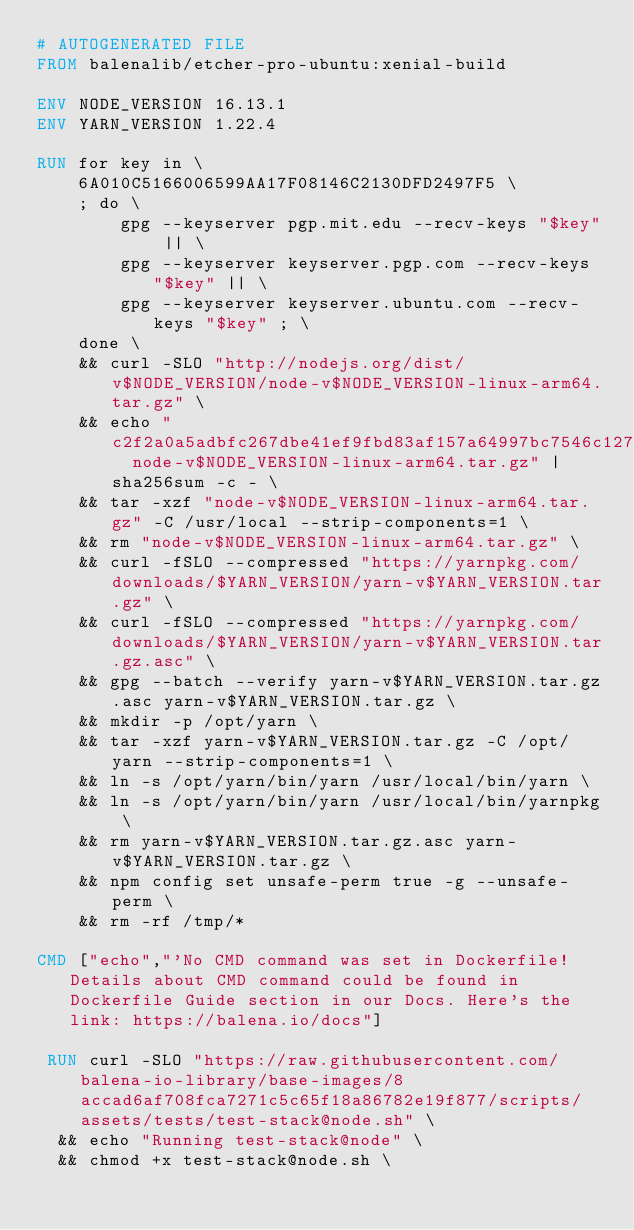Convert code to text. <code><loc_0><loc_0><loc_500><loc_500><_Dockerfile_># AUTOGENERATED FILE
FROM balenalib/etcher-pro-ubuntu:xenial-build

ENV NODE_VERSION 16.13.1
ENV YARN_VERSION 1.22.4

RUN for key in \
	6A010C5166006599AA17F08146C2130DFD2497F5 \
	; do \
		gpg --keyserver pgp.mit.edu --recv-keys "$key" || \
		gpg --keyserver keyserver.pgp.com --recv-keys "$key" || \
		gpg --keyserver keyserver.ubuntu.com --recv-keys "$key" ; \
	done \
	&& curl -SLO "http://nodejs.org/dist/v$NODE_VERSION/node-v$NODE_VERSION-linux-arm64.tar.gz" \
	&& echo "c2f2a0a5adbfc267dbe41ef9fbd83af157a64997bc7546c12717ff55ea6b57d8  node-v$NODE_VERSION-linux-arm64.tar.gz" | sha256sum -c - \
	&& tar -xzf "node-v$NODE_VERSION-linux-arm64.tar.gz" -C /usr/local --strip-components=1 \
	&& rm "node-v$NODE_VERSION-linux-arm64.tar.gz" \
	&& curl -fSLO --compressed "https://yarnpkg.com/downloads/$YARN_VERSION/yarn-v$YARN_VERSION.tar.gz" \
	&& curl -fSLO --compressed "https://yarnpkg.com/downloads/$YARN_VERSION/yarn-v$YARN_VERSION.tar.gz.asc" \
	&& gpg --batch --verify yarn-v$YARN_VERSION.tar.gz.asc yarn-v$YARN_VERSION.tar.gz \
	&& mkdir -p /opt/yarn \
	&& tar -xzf yarn-v$YARN_VERSION.tar.gz -C /opt/yarn --strip-components=1 \
	&& ln -s /opt/yarn/bin/yarn /usr/local/bin/yarn \
	&& ln -s /opt/yarn/bin/yarn /usr/local/bin/yarnpkg \
	&& rm yarn-v$YARN_VERSION.tar.gz.asc yarn-v$YARN_VERSION.tar.gz \
	&& npm config set unsafe-perm true -g --unsafe-perm \
	&& rm -rf /tmp/*

CMD ["echo","'No CMD command was set in Dockerfile! Details about CMD command could be found in Dockerfile Guide section in our Docs. Here's the link: https://balena.io/docs"]

 RUN curl -SLO "https://raw.githubusercontent.com/balena-io-library/base-images/8accad6af708fca7271c5c65f18a86782e19f877/scripts/assets/tests/test-stack@node.sh" \
  && echo "Running test-stack@node" \
  && chmod +x test-stack@node.sh \</code> 